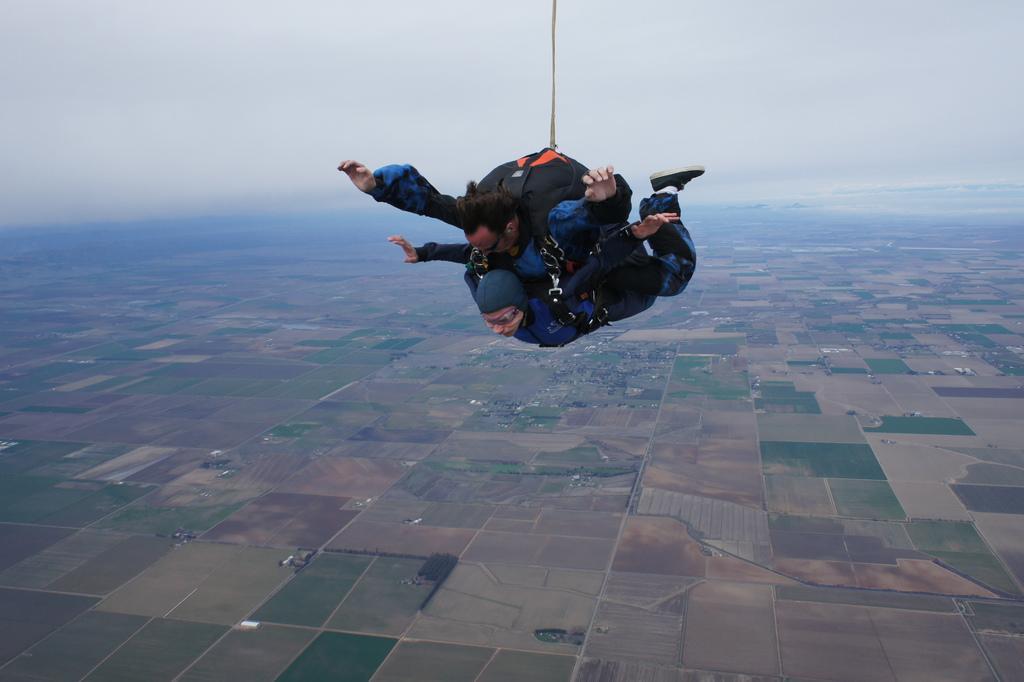In one or two sentences, can you explain what this image depicts? In this image I can see two persons in the air. I can see the ground. In the background I can see the sky. 